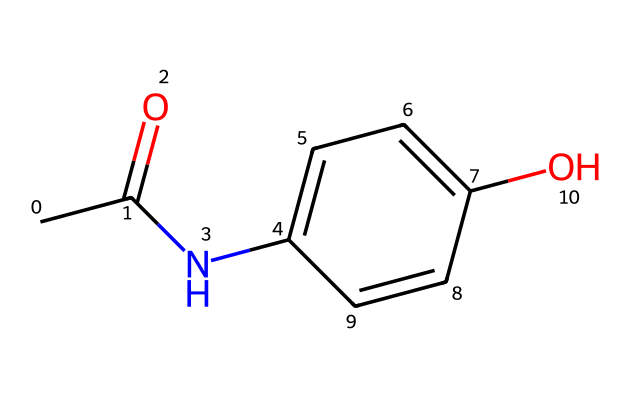What is the molecular formula of acetaminophen? To find the molecular formula, count the number of each type of atom in the SMILES representation. The formula can be derived as follows: 8 carbon (C), 9 hydrogen (H), 1 nitrogen (N), and 2 oxygen (O). This gives the molecular formula C8H9NO2.
Answer: C8H9NO2 How many rings are present in the structure of acetaminophen? By looking at the chemical structure, there is one cyclic component (the benzene ring). The presence of a ring can be deduced from the part designated "C1" in the SMILES, which indicates a ring structure formed by the connected carbon atoms.
Answer: 1 What functional groups are present in acetaminophen? Analyzing the structure shows the presence of an amide group (due to the -NC(=O)- portion) and a hydroxyl group (-OH). The amide contains a nitrogen bonded to a carbonyl and the hydroxyl is associated with the benzene ring.
Answer: amide, hydroxyl What is the number of hydrogen atoms attached to the benzene ring? Count the hydrogen atoms attached to the carbon atoms of the benzene part. Each carbon in the benzene ring typically bonds with one hydrogen atom, and since it has been substituted at one position by the hydroxyl group and another by the amide, only four hydrogens remain bonded to the carbons.
Answer: 4 What type of solid state does acetaminophen predominantly exist in? Acetaminophen typically forms a crystalline solid under normal conditions. Common table salt and sugar relate in this regard as they also exhibit crystalline structures. The orderly arrangement of molecules or ions is indicative of this classification.
Answer: crystalline What is the primary use of acetaminophen in medicine? Acetaminophen is commonly used as a pain reliever and antipyretic. Its ability to reduce fever and alleviate mild to moderate pain makes it a preferred medication in various treatments.
Answer: pain reliever, antipyretic 